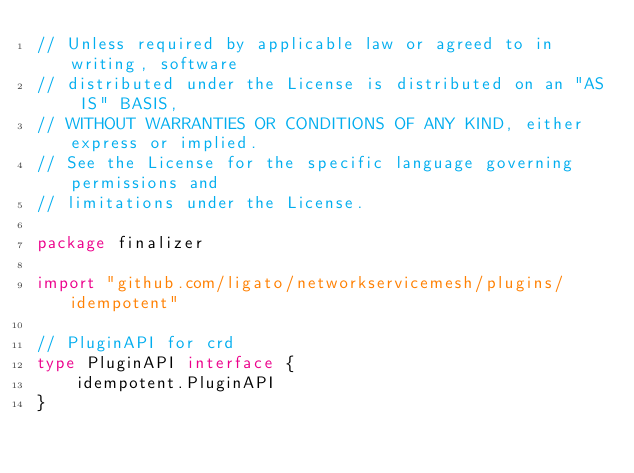Convert code to text. <code><loc_0><loc_0><loc_500><loc_500><_Go_>// Unless required by applicable law or agreed to in writing, software
// distributed under the License is distributed on an "AS IS" BASIS,
// WITHOUT WARRANTIES OR CONDITIONS OF ANY KIND, either express or implied.
// See the License for the specific language governing permissions and
// limitations under the License.

package finalizer

import "github.com/ligato/networkservicemesh/plugins/idempotent"

// PluginAPI for crd
type PluginAPI interface {
	idempotent.PluginAPI
}
</code> 